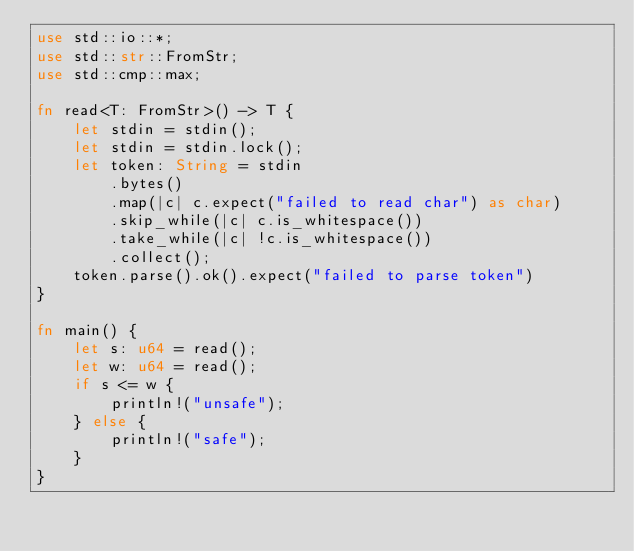Convert code to text. <code><loc_0><loc_0><loc_500><loc_500><_Rust_>use std::io::*;
use std::str::FromStr;
use std::cmp::max;

fn read<T: FromStr>() -> T {
    let stdin = stdin();
    let stdin = stdin.lock();
    let token: String = stdin
        .bytes()
        .map(|c| c.expect("failed to read char") as char) 
        .skip_while(|c| c.is_whitespace())
        .take_while(|c| !c.is_whitespace())
        .collect();
    token.parse().ok().expect("failed to parse token")
}

fn main() {
    let s: u64 = read();
    let w: u64 = read();
    if s <= w {
        println!("unsafe");
    } else {
        println!("safe");
    }
}
</code> 